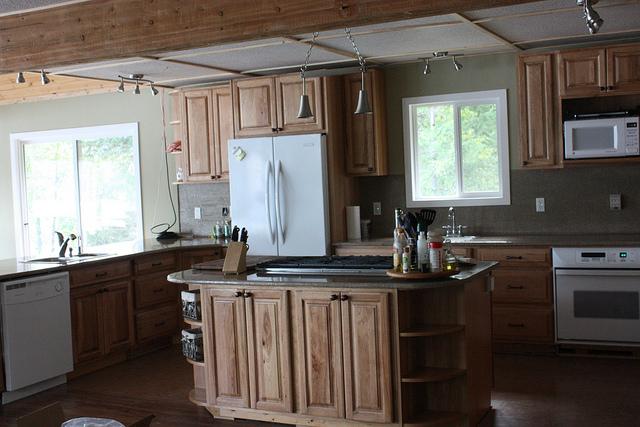Does the appliances in the kitchen matches?
Write a very short answer. Yes. Does this kitchen appear to have ample counter space?
Be succinct. Yes. Is this likely to be a new kitchen?
Give a very brief answer. Yes. Which room is this?
Quick response, please. Kitchen. Is this a fancy kitchen?
Be succinct. Yes. What is the orange thing?
Answer briefly. Towel. What is in the appliance on the bottom left?
Give a very brief answer. Dishwasher. What color is the range?
Answer briefly. White. Does someone live here?
Short answer required. Yes. What is this room used for?
Be succinct. Cooking. Do you see a dishwasher?
Give a very brief answer. Yes. 